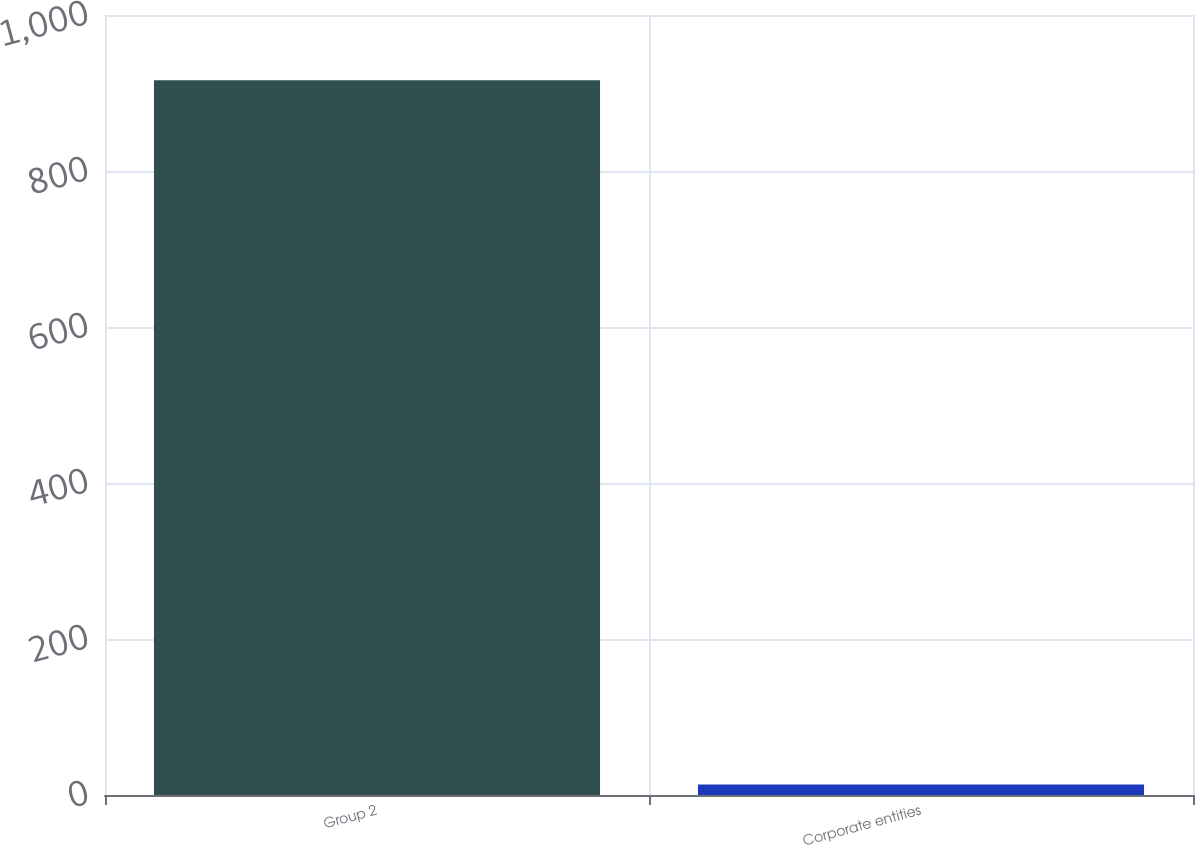Convert chart. <chart><loc_0><loc_0><loc_500><loc_500><bar_chart><fcel>Group 2<fcel>Corporate entities<nl><fcel>916.5<fcel>13.6<nl></chart> 